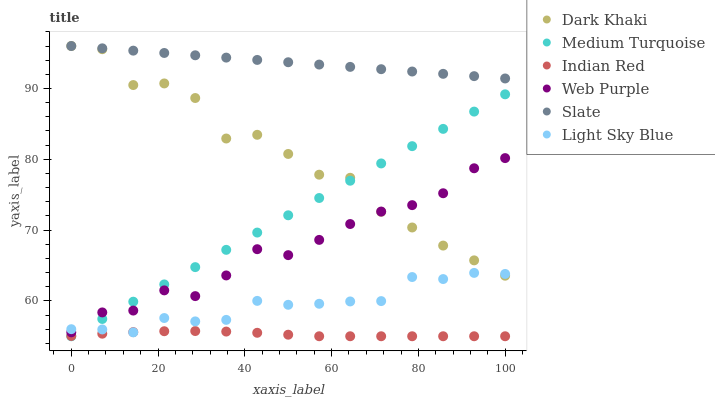Does Indian Red have the minimum area under the curve?
Answer yes or no. Yes. Does Slate have the maximum area under the curve?
Answer yes or no. Yes. Does Dark Khaki have the minimum area under the curve?
Answer yes or no. No. Does Dark Khaki have the maximum area under the curve?
Answer yes or no. No. Is Slate the smoothest?
Answer yes or no. Yes. Is Dark Khaki the roughest?
Answer yes or no. Yes. Is Dark Khaki the smoothest?
Answer yes or no. No. Is Slate the roughest?
Answer yes or no. No. Does Medium Turquoise have the lowest value?
Answer yes or no. Yes. Does Dark Khaki have the lowest value?
Answer yes or no. No. Does Dark Khaki have the highest value?
Answer yes or no. Yes. Does Web Purple have the highest value?
Answer yes or no. No. Is Indian Red less than Web Purple?
Answer yes or no. Yes. Is Slate greater than Medium Turquoise?
Answer yes or no. Yes. Does Light Sky Blue intersect Dark Khaki?
Answer yes or no. Yes. Is Light Sky Blue less than Dark Khaki?
Answer yes or no. No. Is Light Sky Blue greater than Dark Khaki?
Answer yes or no. No. Does Indian Red intersect Web Purple?
Answer yes or no. No. 